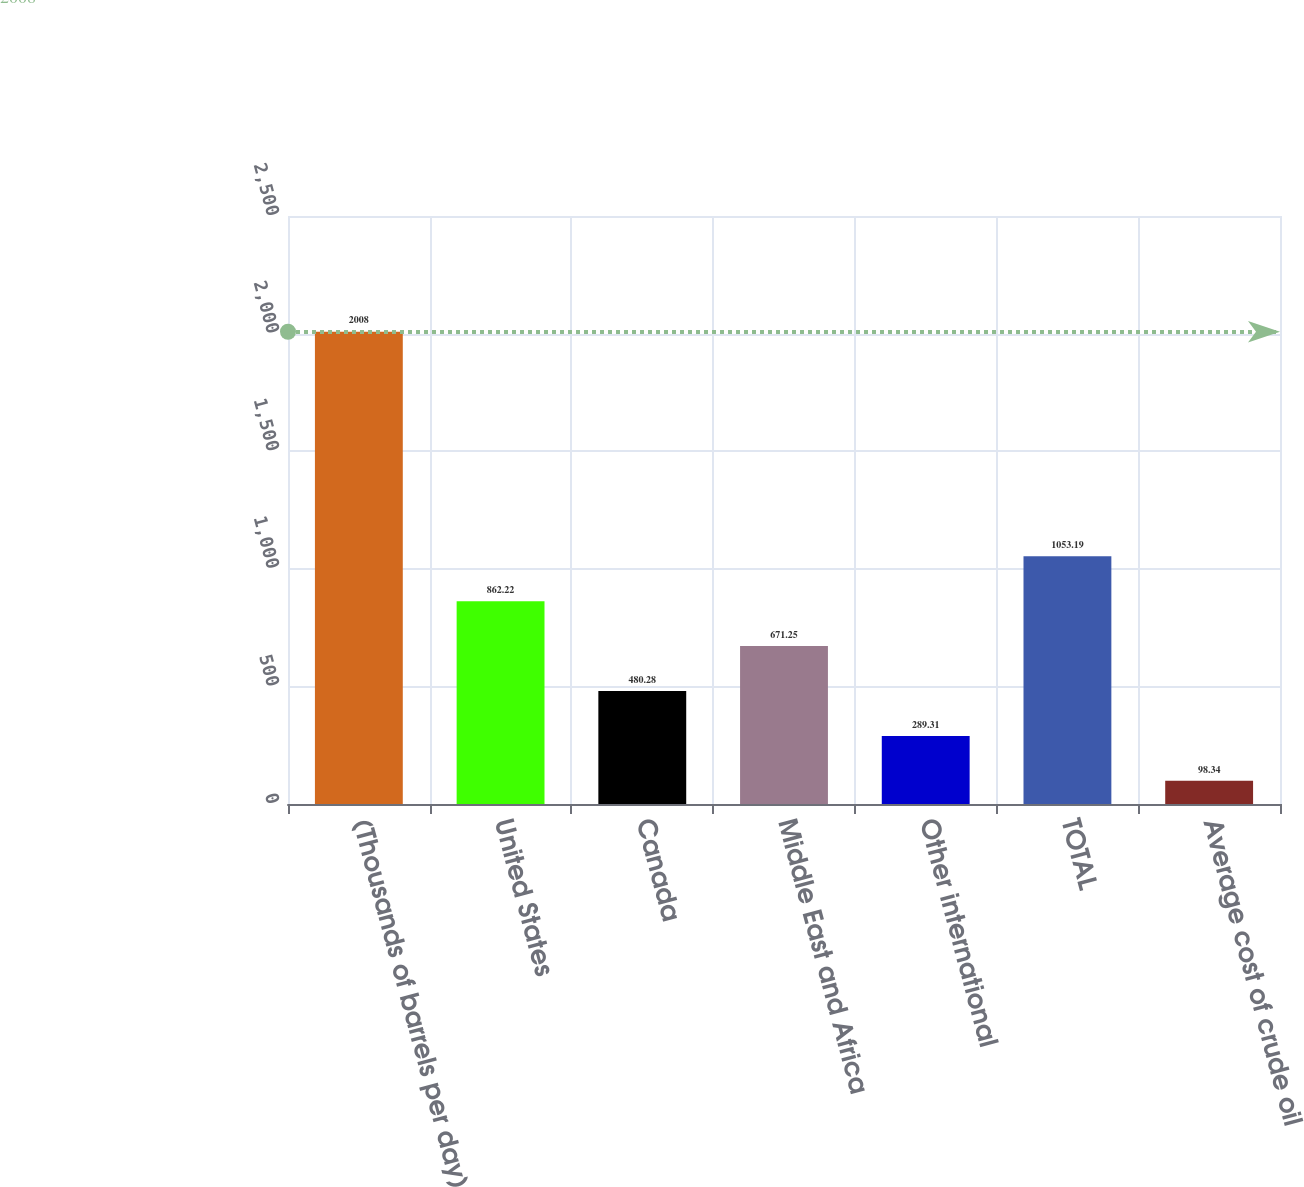Convert chart to OTSL. <chart><loc_0><loc_0><loc_500><loc_500><bar_chart><fcel>(Thousands of barrels per day)<fcel>United States<fcel>Canada<fcel>Middle East and Africa<fcel>Other international<fcel>TOTAL<fcel>Average cost of crude oil<nl><fcel>2008<fcel>862.22<fcel>480.28<fcel>671.25<fcel>289.31<fcel>1053.19<fcel>98.34<nl></chart> 